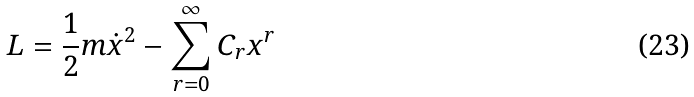<formula> <loc_0><loc_0><loc_500><loc_500>L = \frac { 1 } { 2 } m { \dot { x } } ^ { 2 } - \sum _ { r = 0 } ^ { \infty } C _ { r } x ^ { r }</formula> 